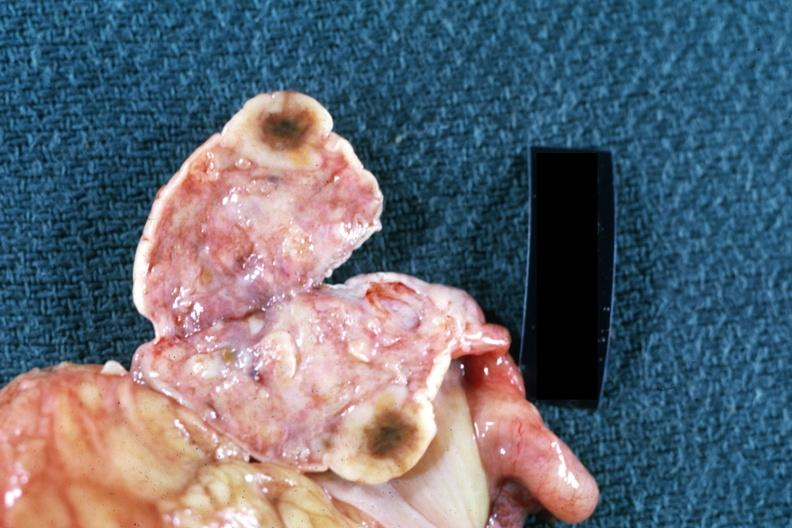what shown breast primary?
Answer the question using a single word or phrase. Close-up single lesion 